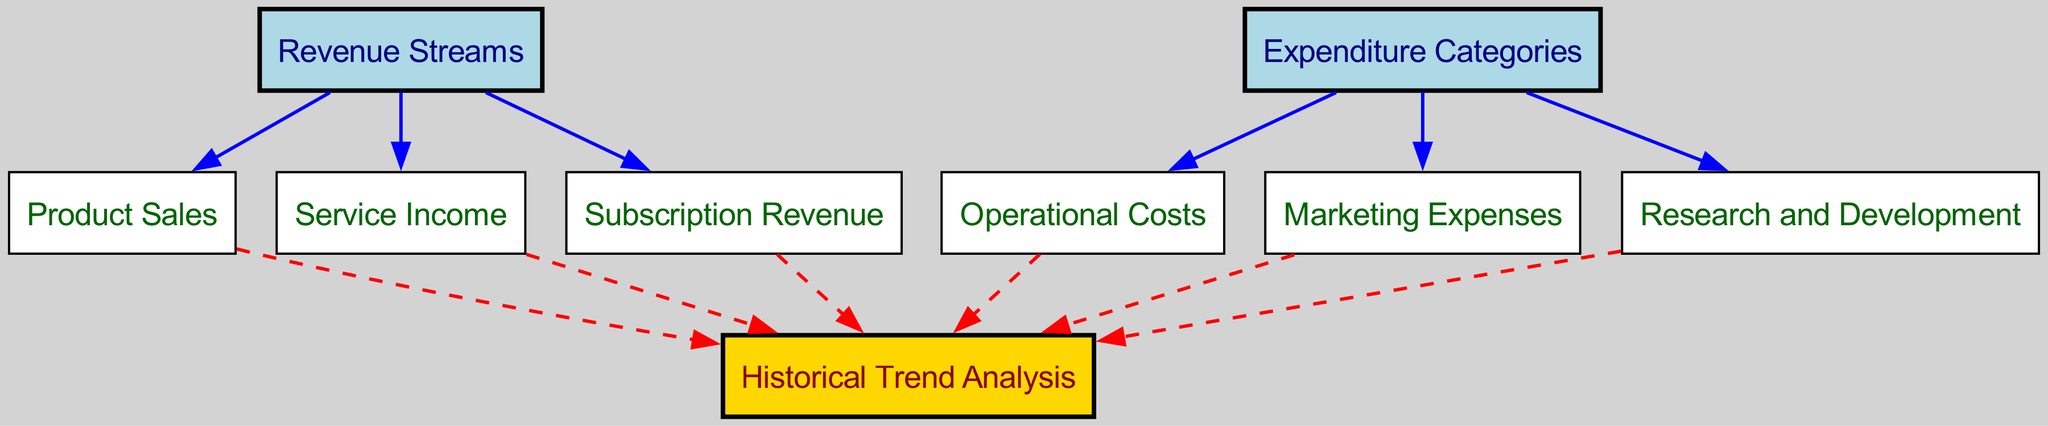What are the three types of revenue streams? The diagram lists three revenue streams: Product Sales, Service Income, and Subscription Revenue. These are represented directly under the node for Revenue Streams, indicating they are the main components of revenue generation.
Answer: Product Sales, Service Income, Subscription Revenue How many expenditure categories are depicted in the diagram? The diagram shows three expenditure categories: Operational Costs, Marketing Expenses, and Research and Development. This can be counted by examining the direct connections from the Expenditure Categories node.
Answer: 3 What is the connection between Service Income and Historical Trend Analysis? The connection is illustrated by a directed edge from Service Income to Historical Trend Analysis, indicating that trends in Service Income are analyzed historically, which is common in financial forecasting.
Answer: Direct Which node is connected to all revenue streams? The node "Historical Trend Analysis" is connected to Product Sales, Service Income, and Subscription Revenue, illustrating that all revenue streams are assessed for historical trends.
Answer: Historical Trend Analysis How many nodes are connected to the Expenditure Categories node? There are three nodes connected to Expenditure Categories: Operational Costs, Marketing Expenses, and Research and Development, as directly shown by the edges stemming from Expenditure Categories.
Answer: 3 Which type of expenses feeds into the Historical Trend Analysis? The edges leading from Operational Costs, Marketing Expenses, and Research and Development to Historical Trend Analysis indicate that these categories of expenditures inform the trend analysis process.
Answer: Operational Costs, Marketing Expenses, Research and Development What color represents the Revenue Streams node? The Revenue Streams node is represented with a light blue color as per the diagram's color coding scheme for different categories of nodes.
Answer: Light blue Is there a direct relationship between Subscription Revenue and Expenditure Categories? No, there is no direct edge connecting Subscription Revenue to Expenditure Categories in the diagram, indicating they function independently in this context.
Answer: No Which edge style is used to connect nodes to Historical Trend Analysis? The edge style connecting nodes to Historical Trend Analysis is dashed, signifying a special relationship where the flow of data or trends is specifically analyzed rather than simply direct influence.
Answer: Dashed 